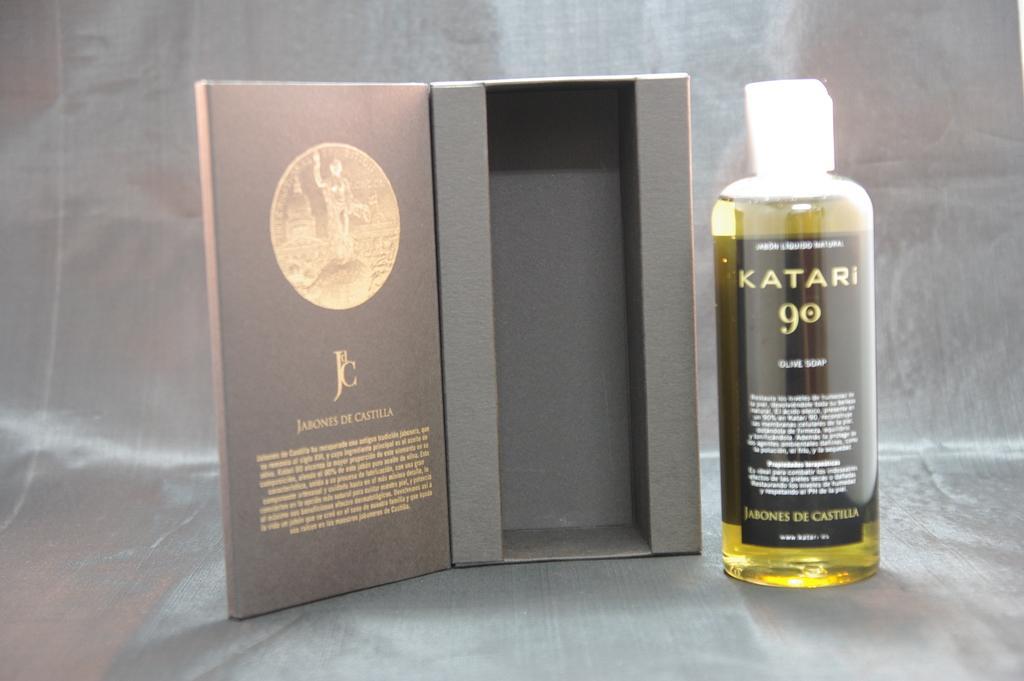Can you describe this image briefly? In this picture there is a black and yellow color perfume bottle on which "katari 90' Is written. Beside there is a black box which is placed on the table. Behind there is a black cover background. 